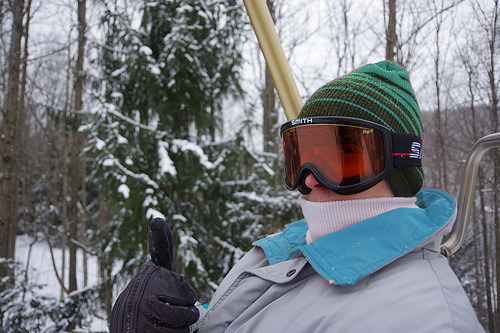<image>
Is there a glasses behind the tree? No. The glasses is not behind the tree. From this viewpoint, the glasses appears to be positioned elsewhere in the scene. 